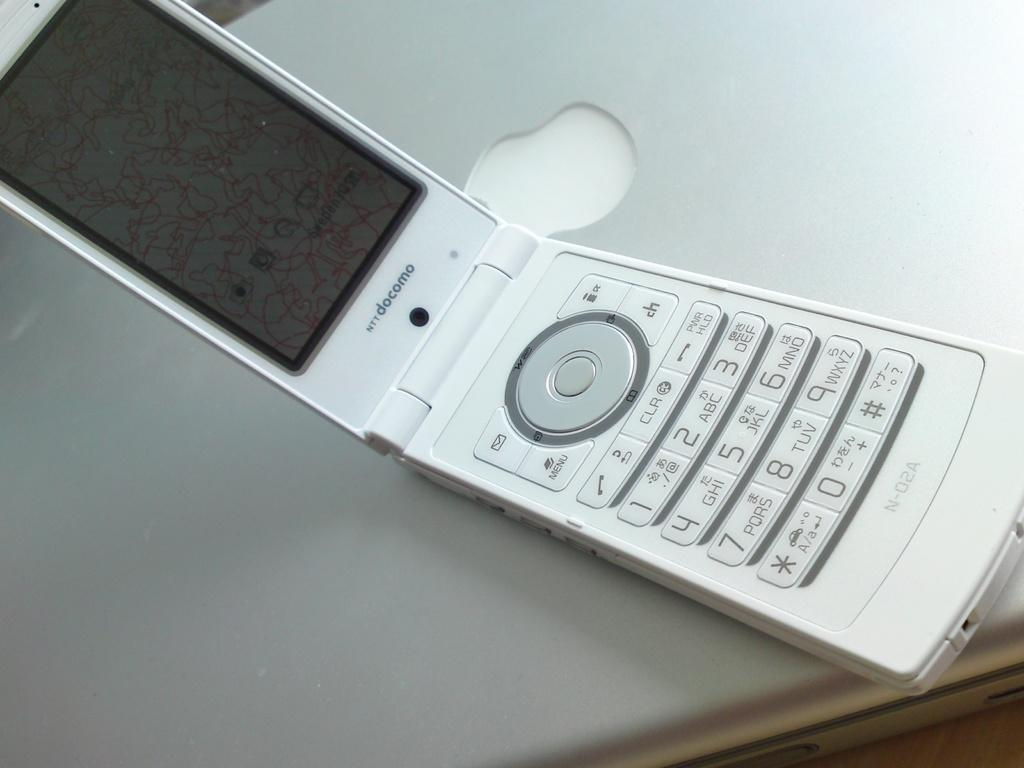<image>
Relay a brief, clear account of the picture shown. A docomo flip phone lies open on a laptop. 